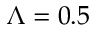<formula> <loc_0><loc_0><loc_500><loc_500>\Lambda = 0 . 5</formula> 